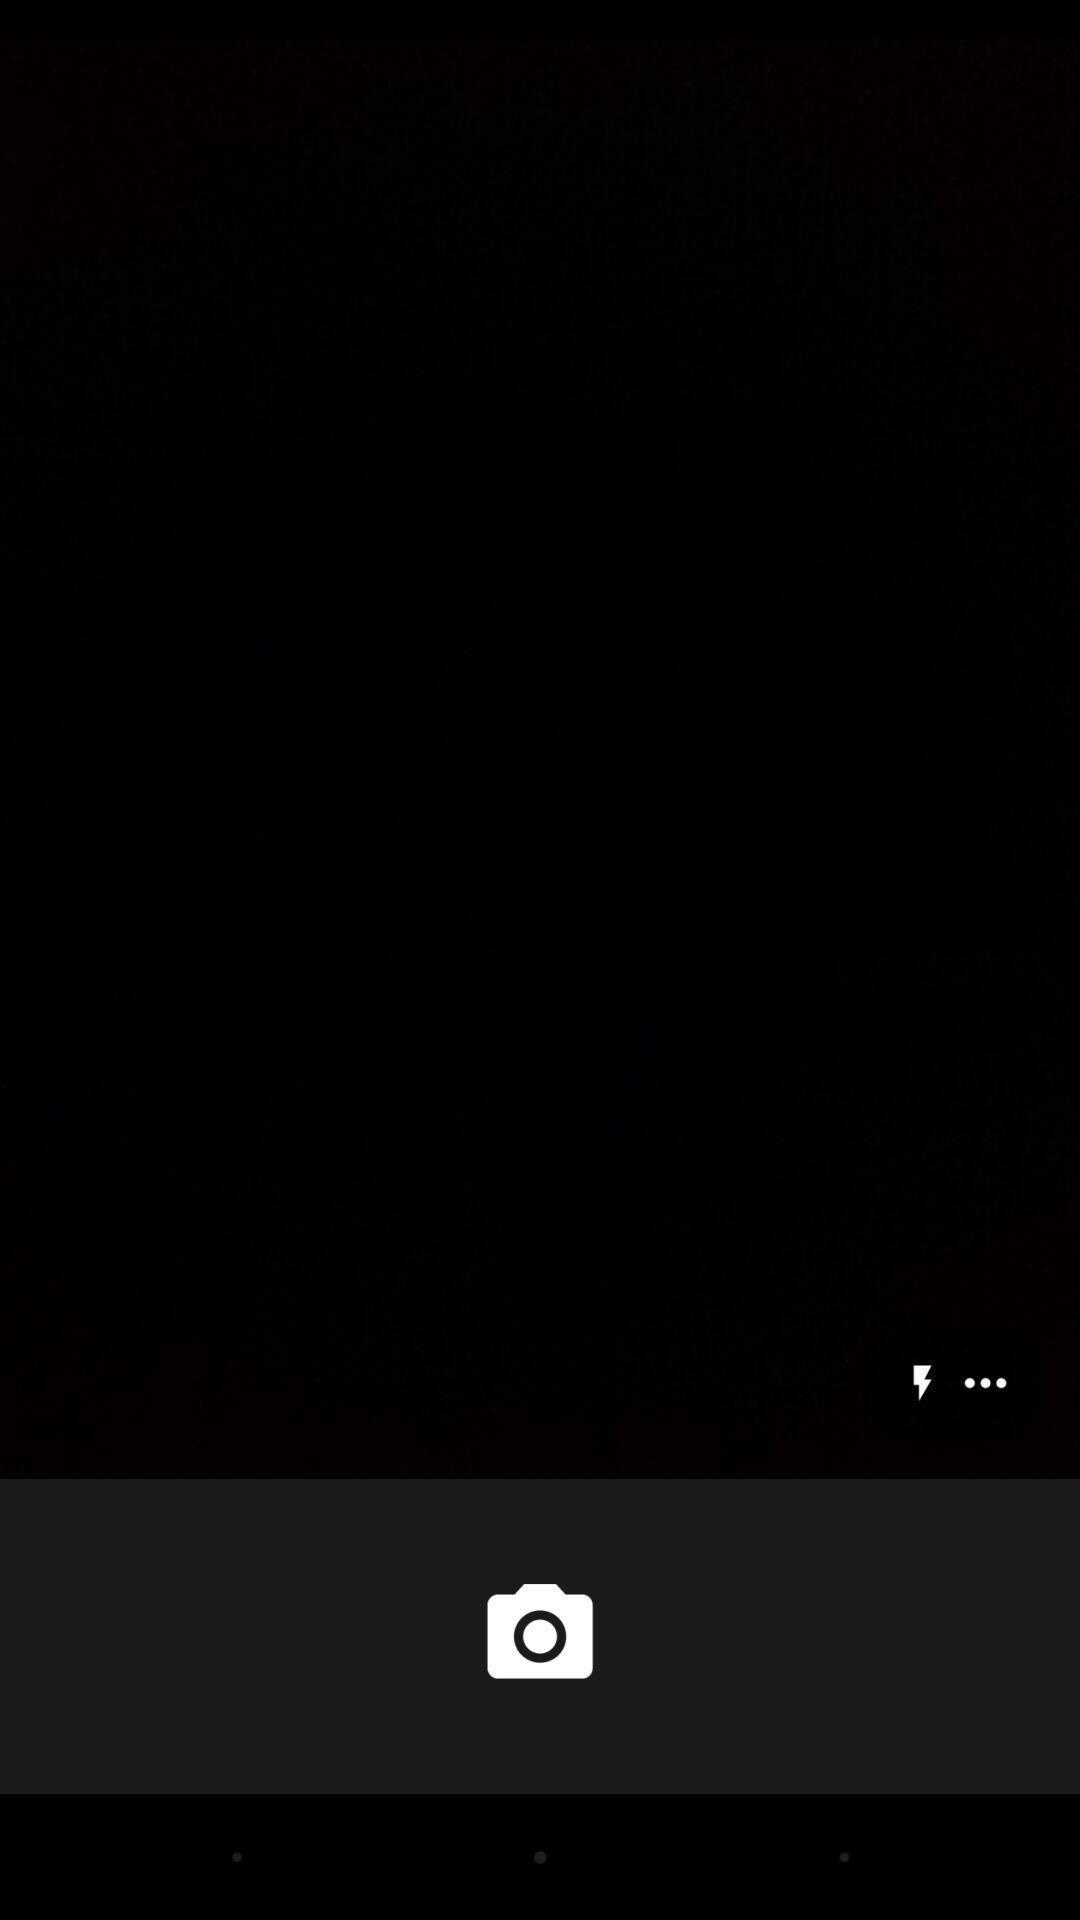Describe the visual elements of this screenshot. Page with camera and flashlight icon. 